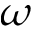<formula> <loc_0><loc_0><loc_500><loc_500>\omega</formula> 